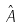Convert formula to latex. <formula><loc_0><loc_0><loc_500><loc_500>\hat { A }</formula> 